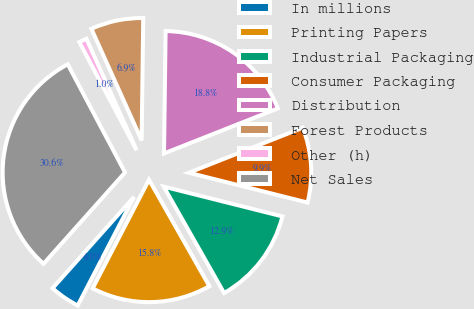<chart> <loc_0><loc_0><loc_500><loc_500><pie_chart><fcel>In millions<fcel>Printing Papers<fcel>Industrial Packaging<fcel>Consumer Packaging<fcel>Distribution<fcel>Forest Products<fcel>Other (h)<fcel>Net Sales<nl><fcel>3.98%<fcel>15.83%<fcel>12.87%<fcel>9.91%<fcel>18.8%<fcel>6.94%<fcel>1.02%<fcel>30.65%<nl></chart> 